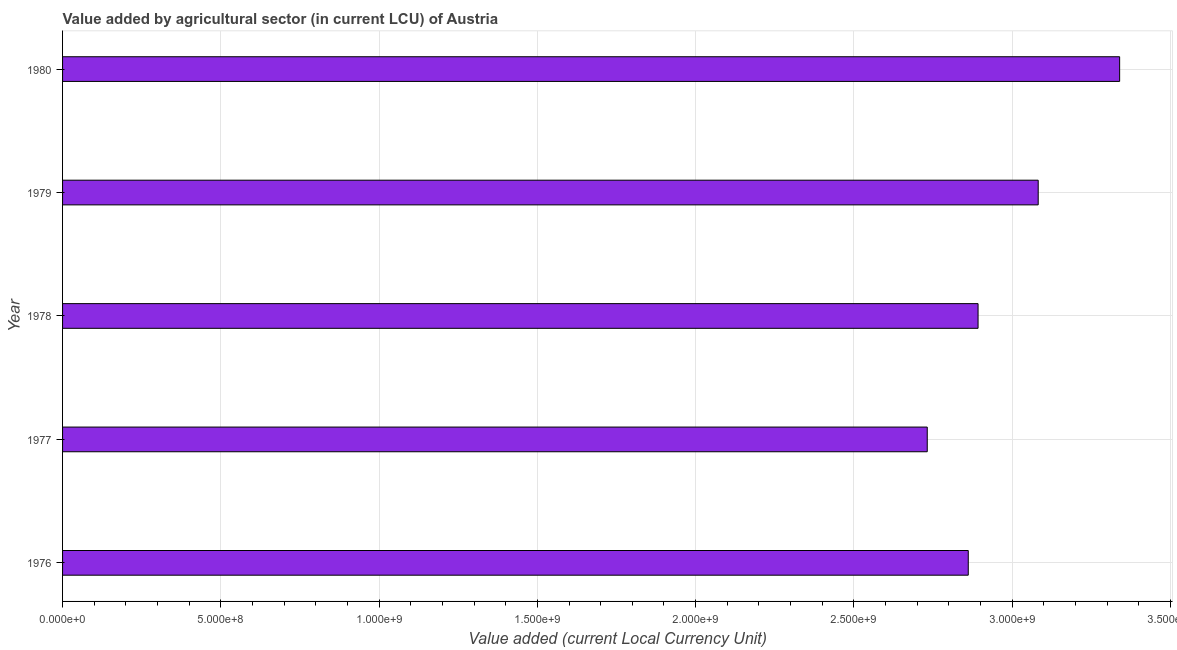Does the graph contain grids?
Your response must be concise. Yes. What is the title of the graph?
Offer a terse response. Value added by agricultural sector (in current LCU) of Austria. What is the label or title of the X-axis?
Provide a short and direct response. Value added (current Local Currency Unit). What is the label or title of the Y-axis?
Your answer should be compact. Year. What is the value added by agriculture sector in 1976?
Provide a succinct answer. 2.86e+09. Across all years, what is the maximum value added by agriculture sector?
Offer a terse response. 3.34e+09. Across all years, what is the minimum value added by agriculture sector?
Make the answer very short. 2.73e+09. In which year was the value added by agriculture sector minimum?
Provide a succinct answer. 1977. What is the sum of the value added by agriculture sector?
Your answer should be very brief. 1.49e+1. What is the difference between the value added by agriculture sector in 1976 and 1980?
Your response must be concise. -4.78e+08. What is the average value added by agriculture sector per year?
Provide a short and direct response. 2.98e+09. What is the median value added by agriculture sector?
Offer a terse response. 2.89e+09. In how many years, is the value added by agriculture sector greater than 900000000 LCU?
Keep it short and to the point. 5. What is the ratio of the value added by agriculture sector in 1978 to that in 1979?
Provide a short and direct response. 0.94. What is the difference between the highest and the second highest value added by agriculture sector?
Your answer should be compact. 2.57e+08. What is the difference between the highest and the lowest value added by agriculture sector?
Make the answer very short. 6.08e+08. In how many years, is the value added by agriculture sector greater than the average value added by agriculture sector taken over all years?
Offer a terse response. 2. Are all the bars in the graph horizontal?
Give a very brief answer. Yes. How many years are there in the graph?
Ensure brevity in your answer.  5. Are the values on the major ticks of X-axis written in scientific E-notation?
Offer a terse response. Yes. What is the Value added (current Local Currency Unit) of 1976?
Provide a succinct answer. 2.86e+09. What is the Value added (current Local Currency Unit) of 1977?
Offer a very short reply. 2.73e+09. What is the Value added (current Local Currency Unit) of 1978?
Your answer should be very brief. 2.89e+09. What is the Value added (current Local Currency Unit) in 1979?
Your response must be concise. 3.08e+09. What is the Value added (current Local Currency Unit) in 1980?
Give a very brief answer. 3.34e+09. What is the difference between the Value added (current Local Currency Unit) in 1976 and 1977?
Make the answer very short. 1.30e+08. What is the difference between the Value added (current Local Currency Unit) in 1976 and 1978?
Keep it short and to the point. -3.10e+07. What is the difference between the Value added (current Local Currency Unit) in 1976 and 1979?
Give a very brief answer. -2.21e+08. What is the difference between the Value added (current Local Currency Unit) in 1976 and 1980?
Keep it short and to the point. -4.78e+08. What is the difference between the Value added (current Local Currency Unit) in 1977 and 1978?
Offer a terse response. -1.61e+08. What is the difference between the Value added (current Local Currency Unit) in 1977 and 1979?
Your answer should be very brief. -3.51e+08. What is the difference between the Value added (current Local Currency Unit) in 1977 and 1980?
Provide a short and direct response. -6.08e+08. What is the difference between the Value added (current Local Currency Unit) in 1978 and 1979?
Make the answer very short. -1.90e+08. What is the difference between the Value added (current Local Currency Unit) in 1978 and 1980?
Give a very brief answer. -4.47e+08. What is the difference between the Value added (current Local Currency Unit) in 1979 and 1980?
Give a very brief answer. -2.57e+08. What is the ratio of the Value added (current Local Currency Unit) in 1976 to that in 1977?
Offer a terse response. 1.05. What is the ratio of the Value added (current Local Currency Unit) in 1976 to that in 1979?
Ensure brevity in your answer.  0.93. What is the ratio of the Value added (current Local Currency Unit) in 1976 to that in 1980?
Ensure brevity in your answer.  0.86. What is the ratio of the Value added (current Local Currency Unit) in 1977 to that in 1978?
Provide a succinct answer. 0.94. What is the ratio of the Value added (current Local Currency Unit) in 1977 to that in 1979?
Offer a terse response. 0.89. What is the ratio of the Value added (current Local Currency Unit) in 1977 to that in 1980?
Your answer should be very brief. 0.82. What is the ratio of the Value added (current Local Currency Unit) in 1978 to that in 1979?
Ensure brevity in your answer.  0.94. What is the ratio of the Value added (current Local Currency Unit) in 1978 to that in 1980?
Give a very brief answer. 0.87. What is the ratio of the Value added (current Local Currency Unit) in 1979 to that in 1980?
Your answer should be very brief. 0.92. 